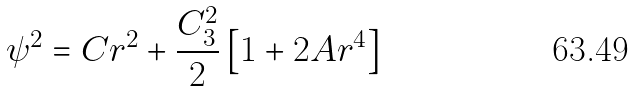Convert formula to latex. <formula><loc_0><loc_0><loc_500><loc_500>\psi ^ { 2 } = C r ^ { 2 } + \frac { C _ { 3 } ^ { 2 } } { 2 } \left [ 1 + 2 A r ^ { 4 } \right ]</formula> 